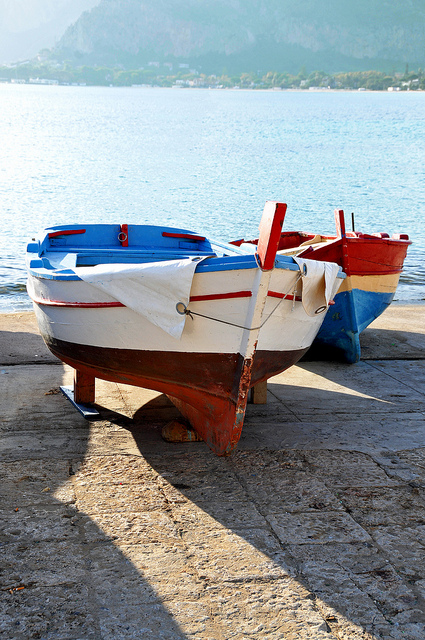<image>Could these bright boats be near the Mediterranean Sea? It is unknown if these bright boats could be near the Mediterranean Sea. Could these bright boats be near the Mediterranean Sea? I don't know if these bright boats could be near the Mediterranean Sea. It is possible but uncertain. 